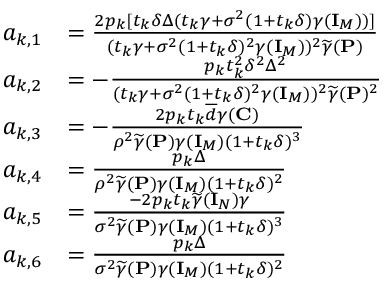Convert formula to latex. <formula><loc_0><loc_0><loc_500><loc_500>\begin{array} { r l } { a _ { k , 1 } } & { = \frac { 2 p _ { k } [ t _ { k } \delta \Delta ( t _ { k } \gamma + \sigma ^ { 2 } ( 1 + t _ { k } \delta ) \gamma ( { I } _ { M } ) ) ] } { ( t _ { k } \gamma + \sigma ^ { 2 } ( 1 + t _ { k } \delta ) ^ { 2 } \gamma ( { I } _ { M } ) ) ^ { 2 } \widetilde { \gamma } ( { P } ) } } \\ { a _ { k , 2 } } & { = - \frac { p _ { k } t _ { k } ^ { 2 } \delta ^ { 2 } \Delta ^ { 2 } } { ( t _ { k } \gamma + \sigma ^ { 2 } ( 1 + t _ { k } \delta ) ^ { 2 } \gamma ( { I } _ { M } ) ) ^ { 2 } \widetilde { \gamma } ( { P } ) ^ { 2 } } } \\ { a _ { k , 3 } } & { = - \frac { 2 p _ { k } t _ { k } \overline { d } \gamma ( { C } ) } { \rho ^ { 2 } \widetilde { \gamma } ( { P } ) \gamma ( { I } _ { M } ) ( 1 + t _ { k } \delta ) ^ { 3 } } } \\ { a _ { k , 4 } } & { = \frac { p _ { k } \Delta } { \rho ^ { 2 } \widetilde { \gamma } ( { P } ) \gamma ( { I } _ { M } ) ( 1 + t _ { k } \delta ) ^ { 2 } } } \\ { a _ { k , 5 } } & { = \frac { - 2 p _ { k } t _ { k } \widetilde { \gamma } ( { I } _ { N } ) \gamma } { \sigma ^ { 2 } \widetilde { \gamma } ( { P } ) \gamma ( { I } _ { M } ) ( 1 + t _ { k } \delta ) ^ { 3 } } } \\ { a _ { k , 6 } } & { = \frac { p _ { k } \Delta } { \sigma ^ { 2 } \widetilde { \gamma } ( { P } ) \gamma ( { I } _ { M } ) ( 1 + t _ { k } \delta ) ^ { 2 } } } \end{array}</formula> 